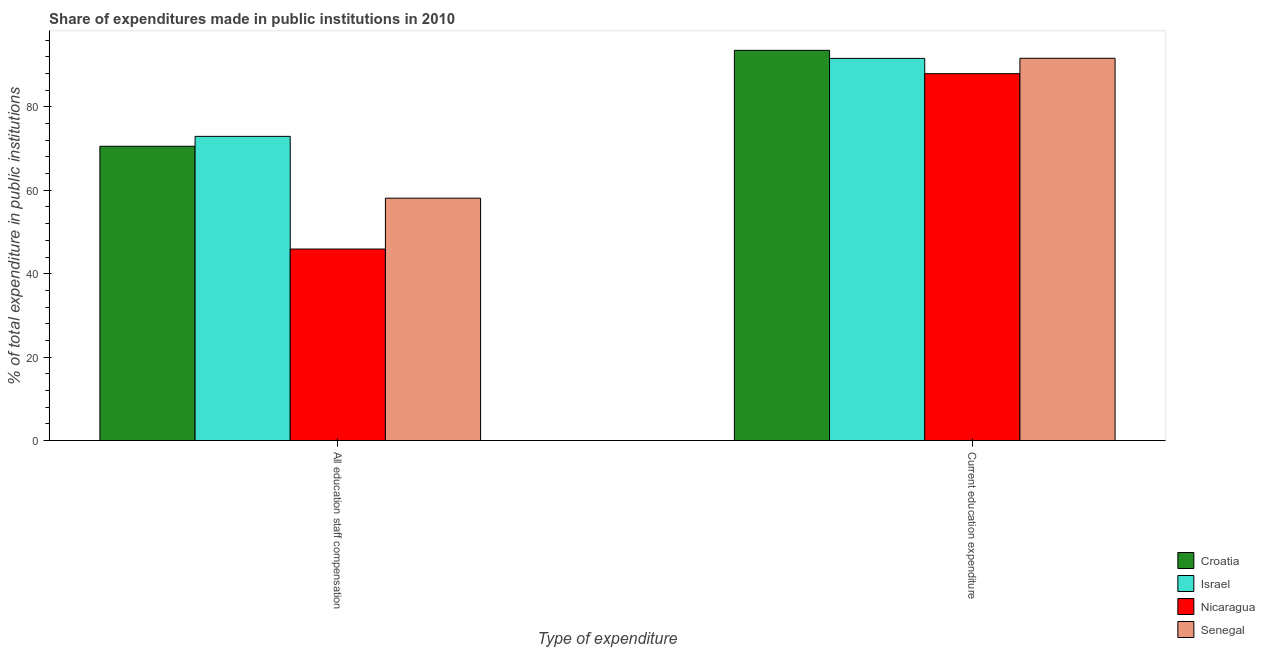Are the number of bars per tick equal to the number of legend labels?
Provide a succinct answer. Yes. Are the number of bars on each tick of the X-axis equal?
Your response must be concise. Yes. What is the label of the 2nd group of bars from the left?
Offer a terse response. Current education expenditure. What is the expenditure in education in Nicaragua?
Ensure brevity in your answer.  87.95. Across all countries, what is the maximum expenditure in education?
Your answer should be compact. 93.55. Across all countries, what is the minimum expenditure in education?
Your answer should be very brief. 87.95. In which country was the expenditure in education maximum?
Make the answer very short. Croatia. In which country was the expenditure in staff compensation minimum?
Keep it short and to the point. Nicaragua. What is the total expenditure in education in the graph?
Give a very brief answer. 364.77. What is the difference between the expenditure in education in Senegal and that in Israel?
Offer a very short reply. 0.03. What is the difference between the expenditure in staff compensation in Senegal and the expenditure in education in Nicaragua?
Give a very brief answer. -29.84. What is the average expenditure in staff compensation per country?
Give a very brief answer. 61.88. What is the difference between the expenditure in staff compensation and expenditure in education in Croatia?
Make the answer very short. -23. In how many countries, is the expenditure in staff compensation greater than 16 %?
Provide a succinct answer. 4. What is the ratio of the expenditure in education in Senegal to that in Croatia?
Provide a succinct answer. 0.98. Is the expenditure in staff compensation in Senegal less than that in Israel?
Offer a very short reply. Yes. What does the 1st bar from the left in All education staff compensation represents?
Make the answer very short. Croatia. What does the 1st bar from the right in All education staff compensation represents?
Keep it short and to the point. Senegal. How many bars are there?
Keep it short and to the point. 8. How many countries are there in the graph?
Provide a succinct answer. 4. What is the difference between two consecutive major ticks on the Y-axis?
Make the answer very short. 20. Are the values on the major ticks of Y-axis written in scientific E-notation?
Your response must be concise. No. Does the graph contain grids?
Keep it short and to the point. No. Where does the legend appear in the graph?
Ensure brevity in your answer.  Bottom right. How many legend labels are there?
Offer a very short reply. 4. How are the legend labels stacked?
Make the answer very short. Vertical. What is the title of the graph?
Your response must be concise. Share of expenditures made in public institutions in 2010. What is the label or title of the X-axis?
Ensure brevity in your answer.  Type of expenditure. What is the label or title of the Y-axis?
Keep it short and to the point. % of total expenditure in public institutions. What is the % of total expenditure in public institutions of Croatia in All education staff compensation?
Offer a very short reply. 70.56. What is the % of total expenditure in public institutions in Israel in All education staff compensation?
Your response must be concise. 72.93. What is the % of total expenditure in public institutions in Nicaragua in All education staff compensation?
Make the answer very short. 45.92. What is the % of total expenditure in public institutions in Senegal in All education staff compensation?
Your response must be concise. 58.11. What is the % of total expenditure in public institutions of Croatia in Current education expenditure?
Ensure brevity in your answer.  93.55. What is the % of total expenditure in public institutions in Israel in Current education expenditure?
Your answer should be very brief. 91.62. What is the % of total expenditure in public institutions of Nicaragua in Current education expenditure?
Your answer should be compact. 87.95. What is the % of total expenditure in public institutions in Senegal in Current education expenditure?
Offer a very short reply. 91.65. Across all Type of expenditure, what is the maximum % of total expenditure in public institutions of Croatia?
Your answer should be very brief. 93.55. Across all Type of expenditure, what is the maximum % of total expenditure in public institutions in Israel?
Provide a succinct answer. 91.62. Across all Type of expenditure, what is the maximum % of total expenditure in public institutions in Nicaragua?
Your response must be concise. 87.95. Across all Type of expenditure, what is the maximum % of total expenditure in public institutions of Senegal?
Your answer should be very brief. 91.65. Across all Type of expenditure, what is the minimum % of total expenditure in public institutions in Croatia?
Your answer should be very brief. 70.56. Across all Type of expenditure, what is the minimum % of total expenditure in public institutions of Israel?
Offer a terse response. 72.93. Across all Type of expenditure, what is the minimum % of total expenditure in public institutions in Nicaragua?
Your answer should be compact. 45.92. Across all Type of expenditure, what is the minimum % of total expenditure in public institutions in Senegal?
Offer a very short reply. 58.11. What is the total % of total expenditure in public institutions in Croatia in the graph?
Offer a very short reply. 164.11. What is the total % of total expenditure in public institutions of Israel in the graph?
Your answer should be very brief. 164.55. What is the total % of total expenditure in public institutions of Nicaragua in the graph?
Provide a succinct answer. 133.87. What is the total % of total expenditure in public institutions in Senegal in the graph?
Your response must be concise. 149.76. What is the difference between the % of total expenditure in public institutions in Croatia in All education staff compensation and that in Current education expenditure?
Offer a very short reply. -23. What is the difference between the % of total expenditure in public institutions of Israel in All education staff compensation and that in Current education expenditure?
Provide a succinct answer. -18.69. What is the difference between the % of total expenditure in public institutions of Nicaragua in All education staff compensation and that in Current education expenditure?
Ensure brevity in your answer.  -42.04. What is the difference between the % of total expenditure in public institutions in Senegal in All education staff compensation and that in Current education expenditure?
Ensure brevity in your answer.  -33.54. What is the difference between the % of total expenditure in public institutions of Croatia in All education staff compensation and the % of total expenditure in public institutions of Israel in Current education expenditure?
Ensure brevity in your answer.  -21.06. What is the difference between the % of total expenditure in public institutions in Croatia in All education staff compensation and the % of total expenditure in public institutions in Nicaragua in Current education expenditure?
Offer a terse response. -17.4. What is the difference between the % of total expenditure in public institutions of Croatia in All education staff compensation and the % of total expenditure in public institutions of Senegal in Current education expenditure?
Make the answer very short. -21.09. What is the difference between the % of total expenditure in public institutions of Israel in All education staff compensation and the % of total expenditure in public institutions of Nicaragua in Current education expenditure?
Ensure brevity in your answer.  -15.03. What is the difference between the % of total expenditure in public institutions of Israel in All education staff compensation and the % of total expenditure in public institutions of Senegal in Current education expenditure?
Your response must be concise. -18.72. What is the difference between the % of total expenditure in public institutions in Nicaragua in All education staff compensation and the % of total expenditure in public institutions in Senegal in Current education expenditure?
Your response must be concise. -45.73. What is the average % of total expenditure in public institutions in Croatia per Type of expenditure?
Your answer should be very brief. 82.05. What is the average % of total expenditure in public institutions in Israel per Type of expenditure?
Offer a terse response. 82.27. What is the average % of total expenditure in public institutions in Nicaragua per Type of expenditure?
Your answer should be compact. 66.94. What is the average % of total expenditure in public institutions in Senegal per Type of expenditure?
Your answer should be very brief. 74.88. What is the difference between the % of total expenditure in public institutions in Croatia and % of total expenditure in public institutions in Israel in All education staff compensation?
Ensure brevity in your answer.  -2.37. What is the difference between the % of total expenditure in public institutions of Croatia and % of total expenditure in public institutions of Nicaragua in All education staff compensation?
Provide a succinct answer. 24.64. What is the difference between the % of total expenditure in public institutions in Croatia and % of total expenditure in public institutions in Senegal in All education staff compensation?
Your answer should be compact. 12.45. What is the difference between the % of total expenditure in public institutions of Israel and % of total expenditure in public institutions of Nicaragua in All education staff compensation?
Keep it short and to the point. 27.01. What is the difference between the % of total expenditure in public institutions in Israel and % of total expenditure in public institutions in Senegal in All education staff compensation?
Provide a short and direct response. 14.82. What is the difference between the % of total expenditure in public institutions in Nicaragua and % of total expenditure in public institutions in Senegal in All education staff compensation?
Provide a succinct answer. -12.19. What is the difference between the % of total expenditure in public institutions in Croatia and % of total expenditure in public institutions in Israel in Current education expenditure?
Keep it short and to the point. 1.93. What is the difference between the % of total expenditure in public institutions of Croatia and % of total expenditure in public institutions of Nicaragua in Current education expenditure?
Your response must be concise. 5.6. What is the difference between the % of total expenditure in public institutions of Croatia and % of total expenditure in public institutions of Senegal in Current education expenditure?
Give a very brief answer. 1.91. What is the difference between the % of total expenditure in public institutions in Israel and % of total expenditure in public institutions in Nicaragua in Current education expenditure?
Your response must be concise. 3.67. What is the difference between the % of total expenditure in public institutions in Israel and % of total expenditure in public institutions in Senegal in Current education expenditure?
Provide a succinct answer. -0.03. What is the difference between the % of total expenditure in public institutions of Nicaragua and % of total expenditure in public institutions of Senegal in Current education expenditure?
Make the answer very short. -3.69. What is the ratio of the % of total expenditure in public institutions of Croatia in All education staff compensation to that in Current education expenditure?
Give a very brief answer. 0.75. What is the ratio of the % of total expenditure in public institutions of Israel in All education staff compensation to that in Current education expenditure?
Give a very brief answer. 0.8. What is the ratio of the % of total expenditure in public institutions in Nicaragua in All education staff compensation to that in Current education expenditure?
Your response must be concise. 0.52. What is the ratio of the % of total expenditure in public institutions in Senegal in All education staff compensation to that in Current education expenditure?
Provide a succinct answer. 0.63. What is the difference between the highest and the second highest % of total expenditure in public institutions of Croatia?
Offer a terse response. 23. What is the difference between the highest and the second highest % of total expenditure in public institutions in Israel?
Keep it short and to the point. 18.69. What is the difference between the highest and the second highest % of total expenditure in public institutions in Nicaragua?
Your answer should be very brief. 42.04. What is the difference between the highest and the second highest % of total expenditure in public institutions in Senegal?
Your answer should be very brief. 33.54. What is the difference between the highest and the lowest % of total expenditure in public institutions of Croatia?
Your response must be concise. 23. What is the difference between the highest and the lowest % of total expenditure in public institutions of Israel?
Ensure brevity in your answer.  18.69. What is the difference between the highest and the lowest % of total expenditure in public institutions of Nicaragua?
Provide a succinct answer. 42.04. What is the difference between the highest and the lowest % of total expenditure in public institutions of Senegal?
Your answer should be very brief. 33.54. 